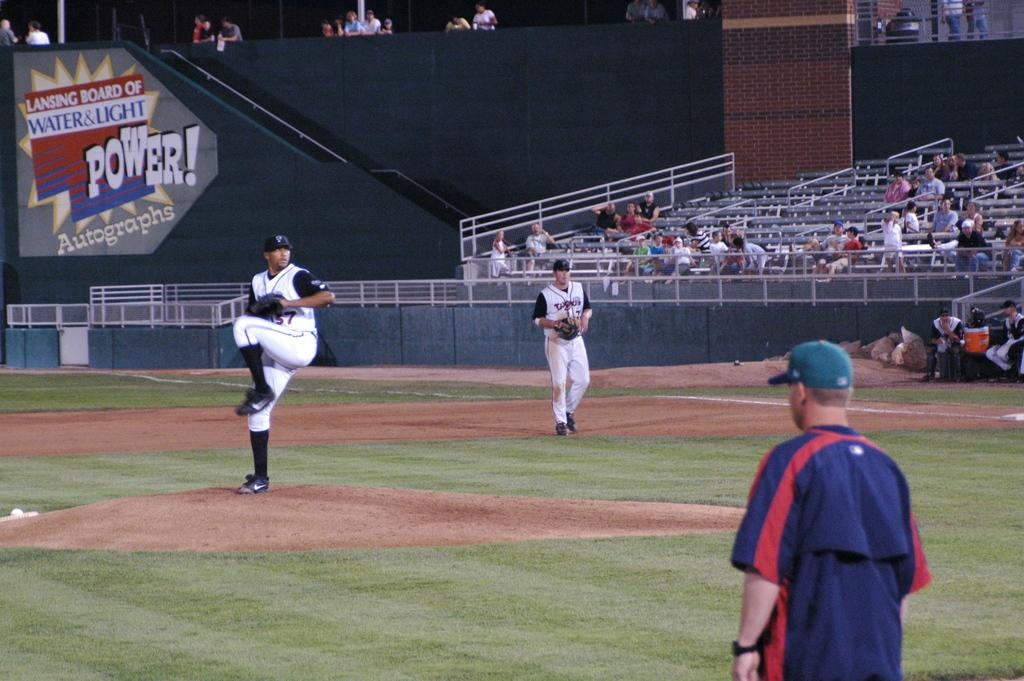Provide a one-sentence caption for the provided image. Power autographs for the players of the baseball game. 